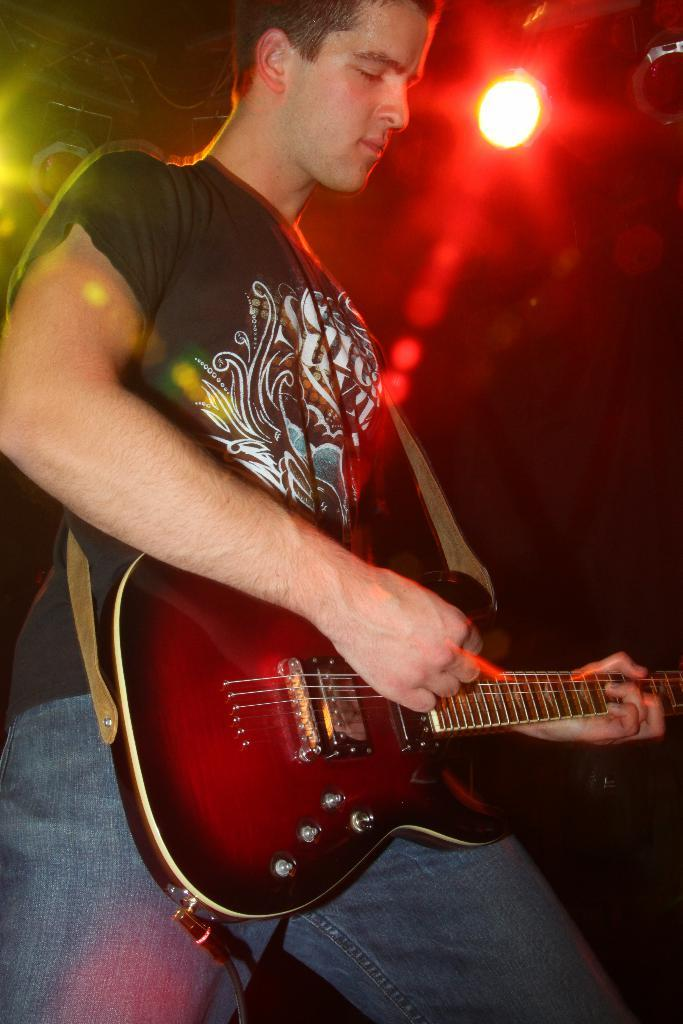Who is the main subject in the image? There is a man in the image. What is the man wearing? The man is wearing a black t-shirt. What object is the man holding? The man is holding a guitar. What can be seen in the background of the image? There is a light in the background of the image. What color is the light? The light is red in color. What is the man's relationship to the person in the image? There is no other person present in the image. --- Facts: 1. There is a car in the image. 2. The car is red in color. 3. The car has four wheels. 4. There are people standing near the car. 5. The people are smiling. Absurd Topics: unicorn, rainbow, magic Conversation: What is the main subject in the image? There is a car in the image. What color is the car? The car is red in color. How many wheels does the car have? The car has four wheels. What are the people near the car doing? There are people standing near the car, and they are smiling. Reasoning: Let's think step by step in order to produce the conversation. We start by identifying the main subject of the image, which is the car. Next, we describe specific features of the car, such as its color and the number of wheels it has. Then, we observe the actions of the people in the image, noting that they are standing near the car and smiling. Finally, we ensure that the language is simple and clear. Absurd Question/Answer: Can you see a unicorn in the image? There is no unicorn present in the image. 